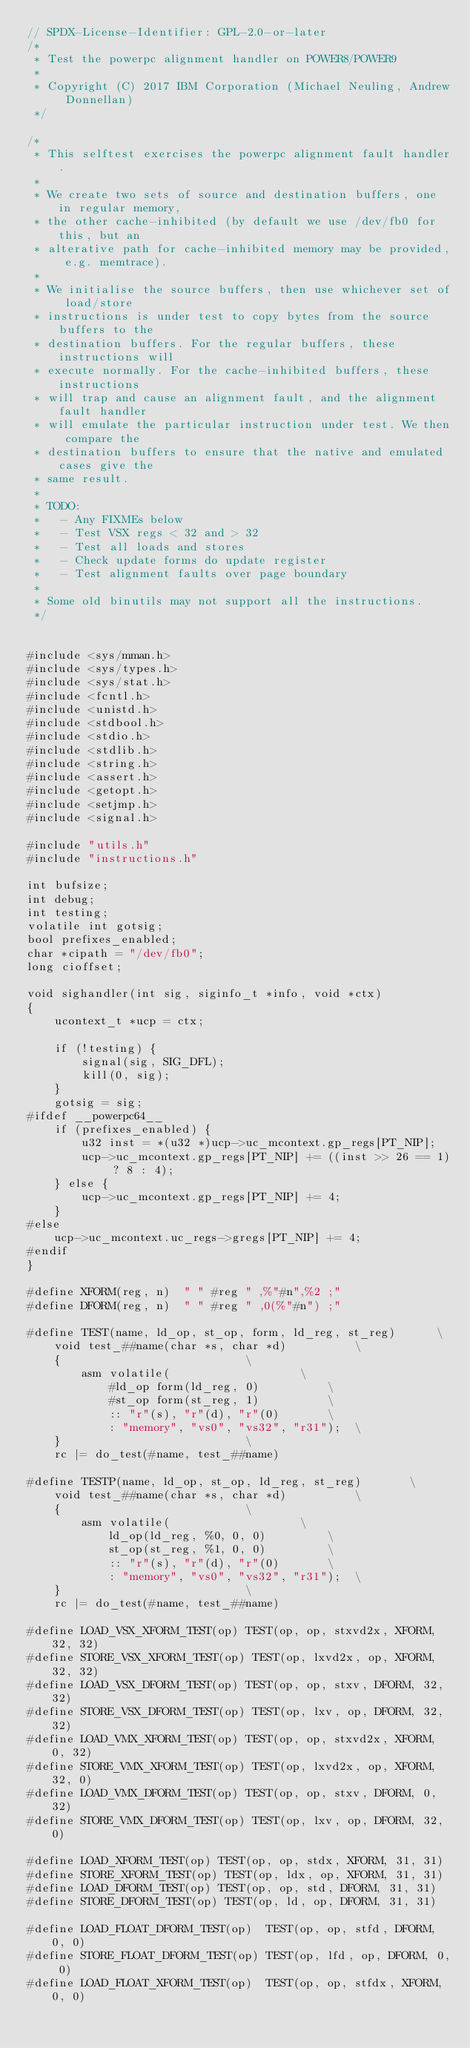<code> <loc_0><loc_0><loc_500><loc_500><_C_>// SPDX-License-Identifier: GPL-2.0-or-later
/*
 * Test the powerpc alignment handler on POWER8/POWER9
 *
 * Copyright (C) 2017 IBM Corporation (Michael Neuling, Andrew Donnellan)
 */

/*
 * This selftest exercises the powerpc alignment fault handler.
 *
 * We create two sets of source and destination buffers, one in regular memory,
 * the other cache-inhibited (by default we use /dev/fb0 for this, but an
 * alterative path for cache-inhibited memory may be provided, e.g. memtrace).
 *
 * We initialise the source buffers, then use whichever set of load/store
 * instructions is under test to copy bytes from the source buffers to the
 * destination buffers. For the regular buffers, these instructions will
 * execute normally. For the cache-inhibited buffers, these instructions
 * will trap and cause an alignment fault, and the alignment fault handler
 * will emulate the particular instruction under test. We then compare the
 * destination buffers to ensure that the native and emulated cases give the
 * same result.
 *
 * TODO:
 *   - Any FIXMEs below
 *   - Test VSX regs < 32 and > 32
 *   - Test all loads and stores
 *   - Check update forms do update register
 *   - Test alignment faults over page boundary
 *
 * Some old binutils may not support all the instructions.
 */


#include <sys/mman.h>
#include <sys/types.h>
#include <sys/stat.h>
#include <fcntl.h>
#include <unistd.h>
#include <stdbool.h>
#include <stdio.h>
#include <stdlib.h>
#include <string.h>
#include <assert.h>
#include <getopt.h>
#include <setjmp.h>
#include <signal.h>

#include "utils.h"
#include "instructions.h"

int bufsize;
int debug;
int testing;
volatile int gotsig;
bool prefixes_enabled;
char *cipath = "/dev/fb0";
long cioffset;

void sighandler(int sig, siginfo_t *info, void *ctx)
{
	ucontext_t *ucp = ctx;

	if (!testing) {
		signal(sig, SIG_DFL);
		kill(0, sig);
	}
	gotsig = sig;
#ifdef __powerpc64__
	if (prefixes_enabled) {
		u32 inst = *(u32 *)ucp->uc_mcontext.gp_regs[PT_NIP];
		ucp->uc_mcontext.gp_regs[PT_NIP] += ((inst >> 26 == 1) ? 8 : 4);
	} else {
		ucp->uc_mcontext.gp_regs[PT_NIP] += 4;
	}
#else
	ucp->uc_mcontext.uc_regs->gregs[PT_NIP] += 4;
#endif
}

#define XFORM(reg, n)  " " #reg " ,%"#n",%2 ;"
#define DFORM(reg, n)  " " #reg " ,0(%"#n") ;"

#define TEST(name, ld_op, st_op, form, ld_reg, st_reg)		\
	void test_##name(char *s, char *d)			\
	{							\
		asm volatile(					\
			#ld_op form(ld_reg, 0)			\
			#st_op form(st_reg, 1)			\
			:: "r"(s), "r"(d), "r"(0)		\
			: "memory", "vs0", "vs32", "r31");	\
	}							\
	rc |= do_test(#name, test_##name)

#define TESTP(name, ld_op, st_op, ld_reg, st_reg)		\
	void test_##name(char *s, char *d)			\
	{							\
		asm volatile(					\
			ld_op(ld_reg, %0, 0, 0)			\
			st_op(st_reg, %1, 0, 0)			\
			:: "r"(s), "r"(d), "r"(0)		\
			: "memory", "vs0", "vs32", "r31");	\
	}							\
	rc |= do_test(#name, test_##name)

#define LOAD_VSX_XFORM_TEST(op) TEST(op, op, stxvd2x, XFORM, 32, 32)
#define STORE_VSX_XFORM_TEST(op) TEST(op, lxvd2x, op, XFORM, 32, 32)
#define LOAD_VSX_DFORM_TEST(op) TEST(op, op, stxv, DFORM, 32, 32)
#define STORE_VSX_DFORM_TEST(op) TEST(op, lxv, op, DFORM, 32, 32)
#define LOAD_VMX_XFORM_TEST(op) TEST(op, op, stxvd2x, XFORM, 0, 32)
#define STORE_VMX_XFORM_TEST(op) TEST(op, lxvd2x, op, XFORM, 32, 0)
#define LOAD_VMX_DFORM_TEST(op) TEST(op, op, stxv, DFORM, 0, 32)
#define STORE_VMX_DFORM_TEST(op) TEST(op, lxv, op, DFORM, 32, 0)

#define LOAD_XFORM_TEST(op) TEST(op, op, stdx, XFORM, 31, 31)
#define STORE_XFORM_TEST(op) TEST(op, ldx, op, XFORM, 31, 31)
#define LOAD_DFORM_TEST(op) TEST(op, op, std, DFORM, 31, 31)
#define STORE_DFORM_TEST(op) TEST(op, ld, op, DFORM, 31, 31)

#define LOAD_FLOAT_DFORM_TEST(op)  TEST(op, op, stfd, DFORM, 0, 0)
#define STORE_FLOAT_DFORM_TEST(op) TEST(op, lfd, op, DFORM, 0, 0)
#define LOAD_FLOAT_XFORM_TEST(op)  TEST(op, op, stfdx, XFORM, 0, 0)</code> 